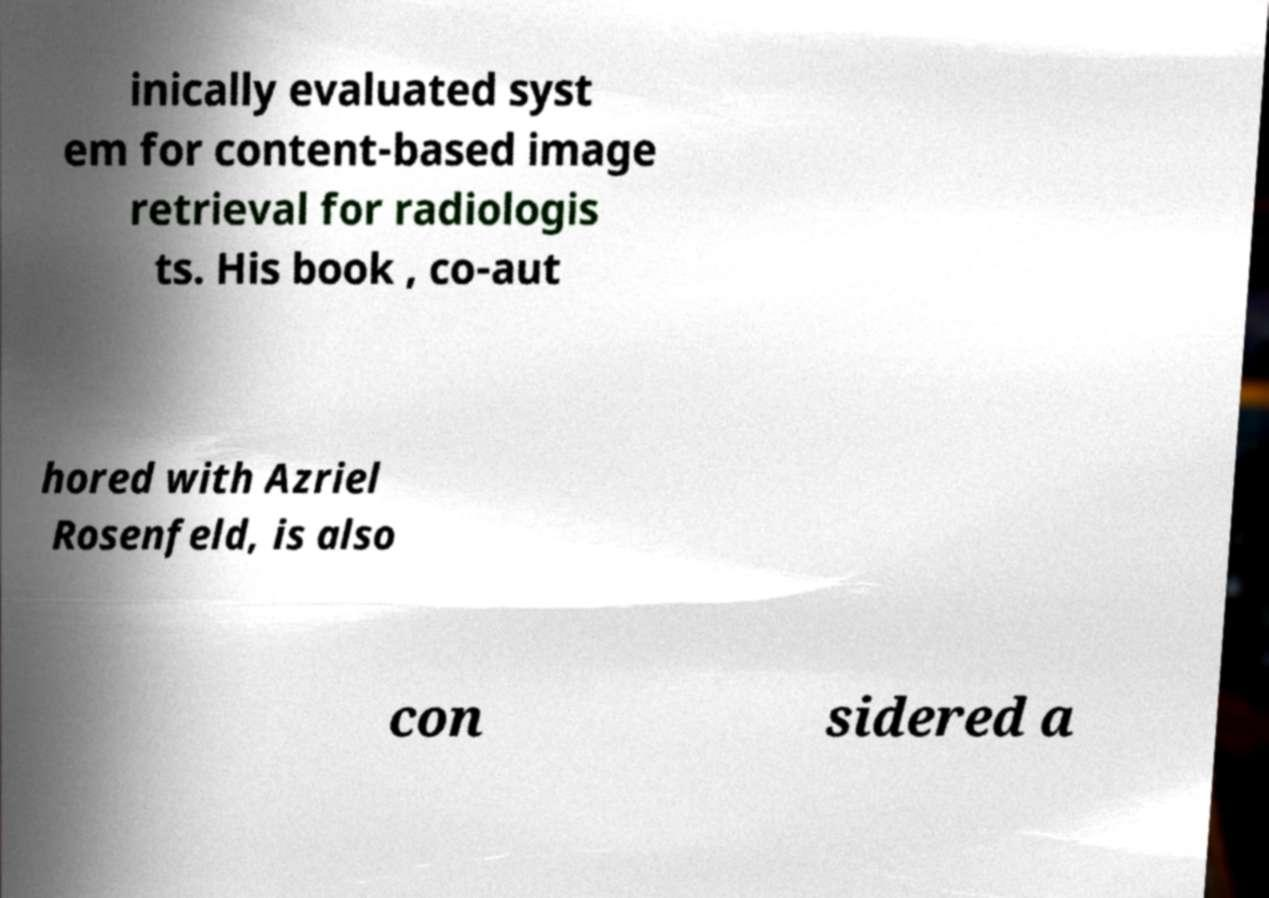Please read and relay the text visible in this image. What does it say? inically evaluated syst em for content-based image retrieval for radiologis ts. His book , co-aut hored with Azriel Rosenfeld, is also con sidered a 